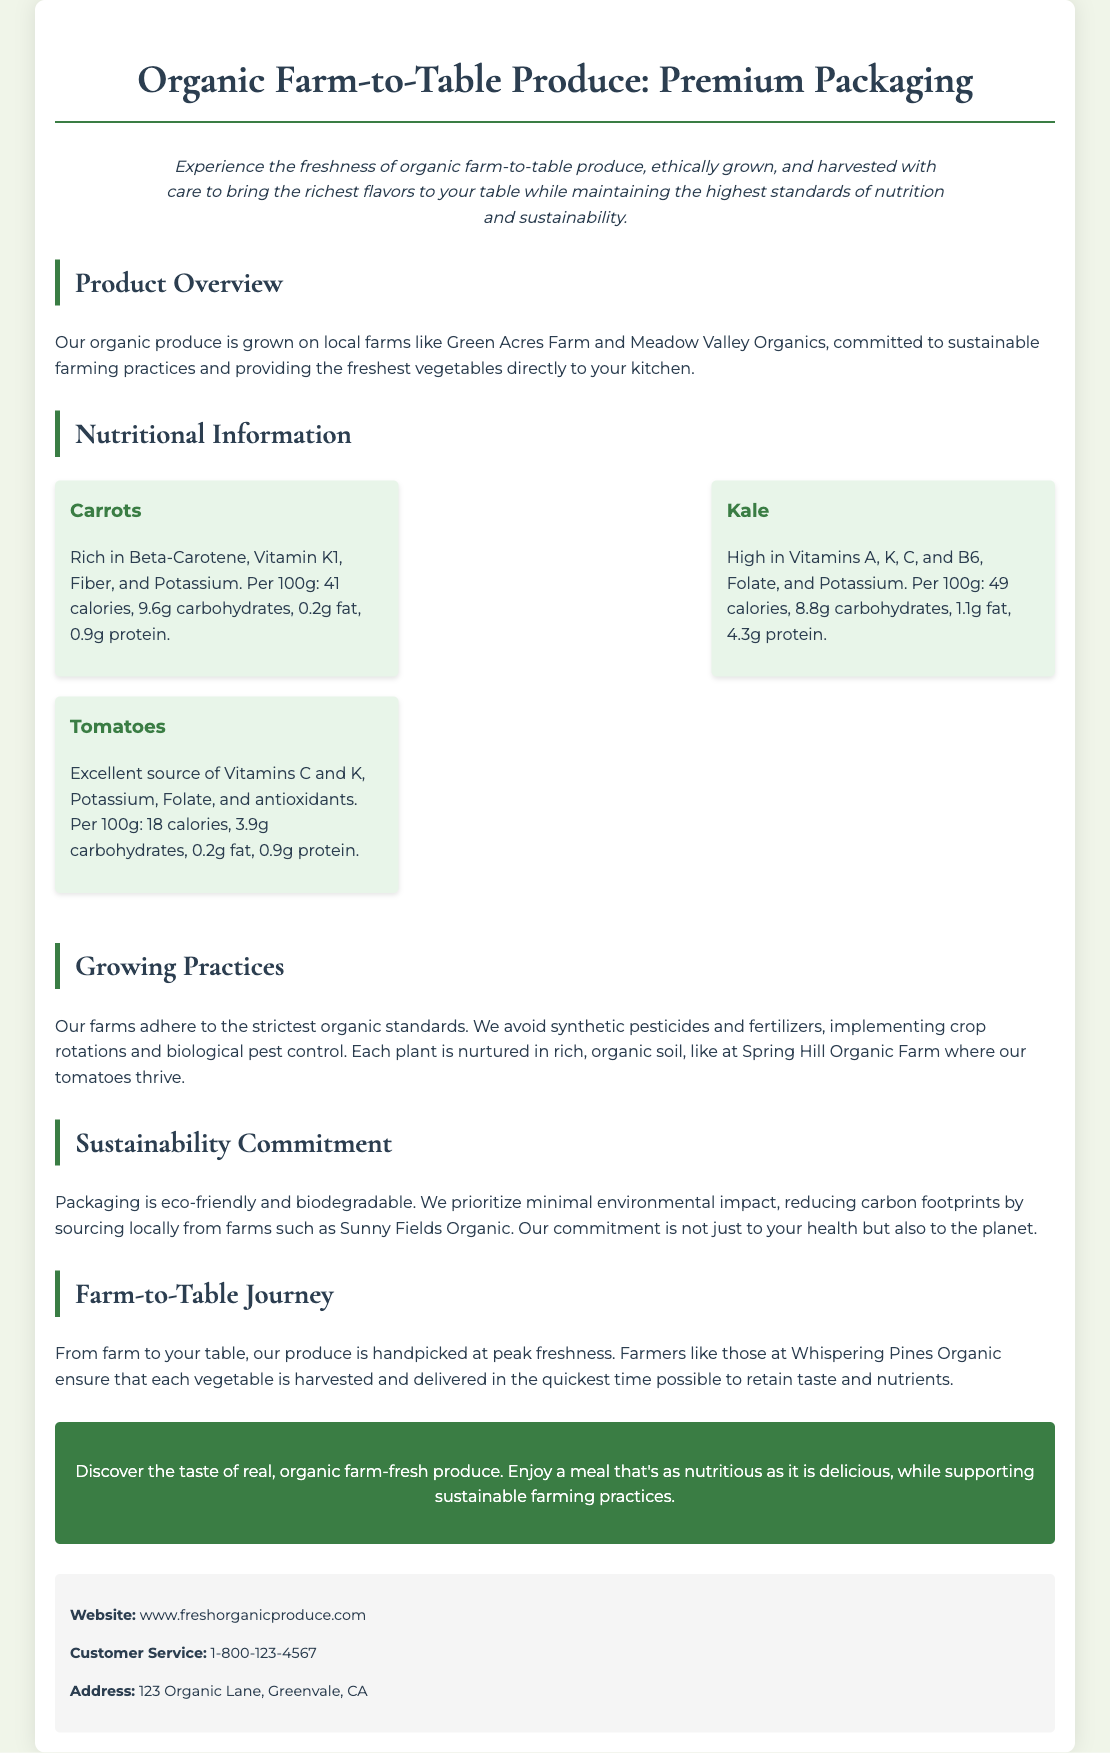what is the title of the document? The title of the document is found in the heading section.
Answer: Organic Farm-to-Table Produce: Premium Packaging what farms are mentioned in the document? The document lists specific farms associated with the produce.
Answer: Green Acres Farm, Meadow Valley Organics, Spring Hill Organic Farm, Sunny Fields Organic, Whispering Pines Organic how many calories are in 100g of Kale? The nutritional information provides the caloric content per 100g for Kale.
Answer: 49 calories what is the main focus of the Sustainability Commitment section? This section discusses the environmental impact and packaging practices.
Answer: Eco-friendly and biodegradable packaging which vitamin is abundant in Tomatoes? The document specifies the vitamins found in tomatoes in the nutritional section.
Answer: Vitamins C and K who is responsible for handpicking the produce? The document explains the role of farmers in ensuring freshness.
Answer: Farmers what is the main growing practice emphasized? The section outlines the farming practices to maintain quality.
Answer: Avoid synthetic pesticides and fertilizers what should consumers discover according to the call-to-action? The call-to-action aims to inform consumers about the benefits of the produce.
Answer: The taste of real, organic farm-fresh produce how are the produce delivered to retain taste and nutrients? The document mentions the method of harvesting and delivering produce.
Answer: Handpicked at peak freshness 